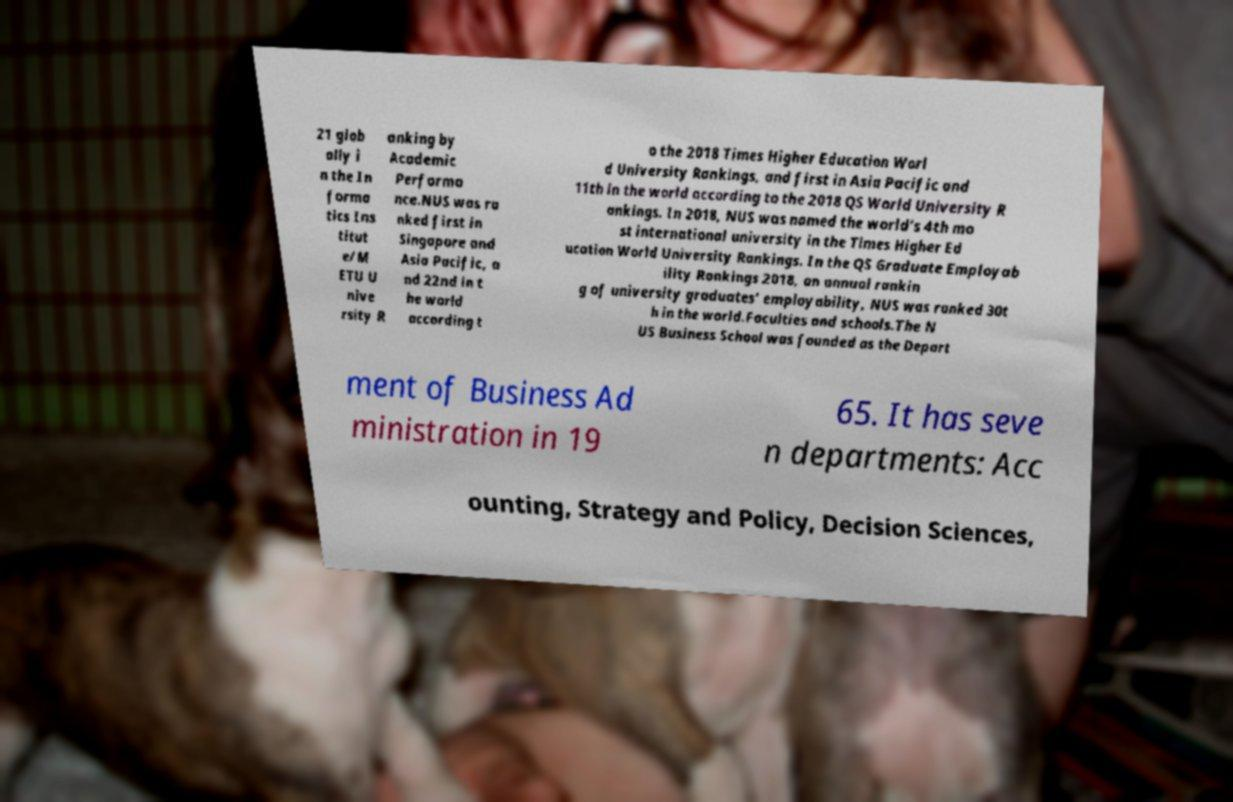What messages or text are displayed in this image? I need them in a readable, typed format. 21 glob ally i n the In forma tics Ins titut e/M ETU U nive rsity R anking by Academic Performa nce.NUS was ra nked first in Singapore and Asia Pacific, a nd 22nd in t he world according t o the 2018 Times Higher Education Worl d University Rankings, and first in Asia Pacific and 11th in the world according to the 2018 QS World University R ankings. In 2018, NUS was named the world's 4th mo st international university in the Times Higher Ed ucation World University Rankings. In the QS Graduate Employab ility Rankings 2018, an annual rankin g of university graduates' employability, NUS was ranked 30t h in the world.Faculties and schools.The N US Business School was founded as the Depart ment of Business Ad ministration in 19 65. It has seve n departments: Acc ounting, Strategy and Policy, Decision Sciences, 